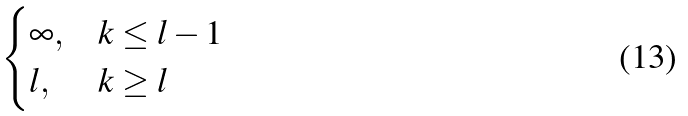<formula> <loc_0><loc_0><loc_500><loc_500>\begin{cases} \infty , & k \leq l - 1 \\ l , & k \geq l \end{cases}</formula> 